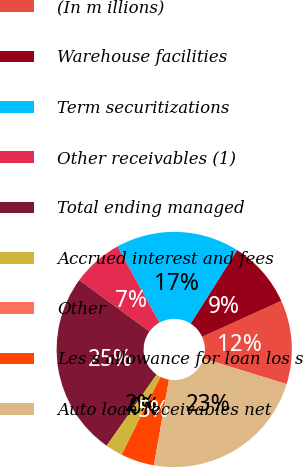Convert chart to OTSL. <chart><loc_0><loc_0><loc_500><loc_500><pie_chart><fcel>(In m illions)<fcel>Warehouse facilities<fcel>Term securitizations<fcel>Other receivables (1)<fcel>Total ending managed<fcel>Accrued interest and fees<fcel>Other<fcel>Les s allowance for loan los s<fcel>Auto loan receivables net<nl><fcel>11.55%<fcel>9.24%<fcel>17.0%<fcel>6.94%<fcel>25.3%<fcel>2.33%<fcel>0.02%<fcel>4.63%<fcel>23.0%<nl></chart> 